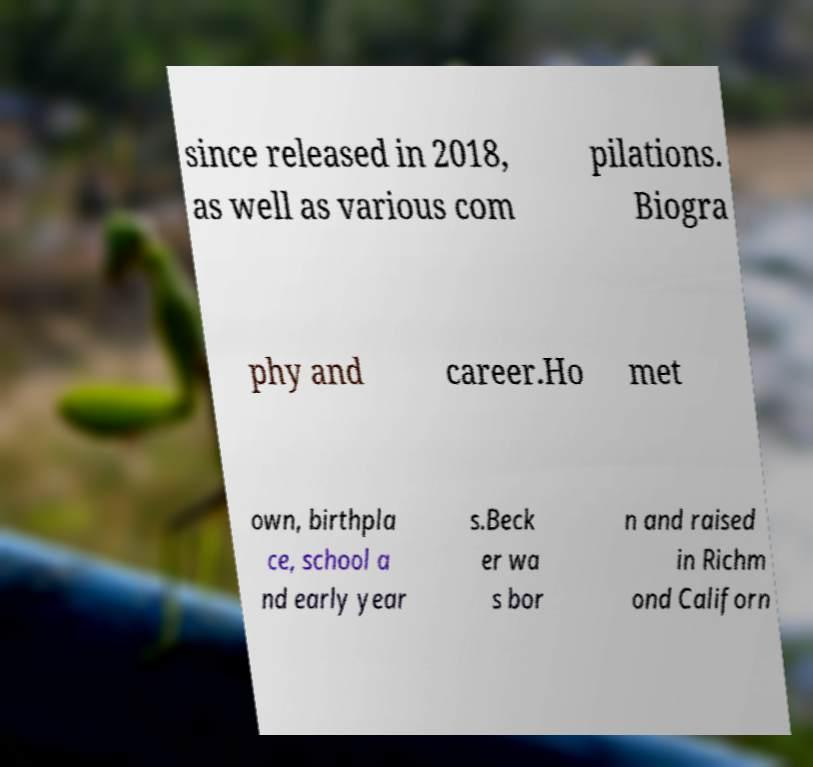Could you extract and type out the text from this image? since released in 2018, as well as various com pilations. Biogra phy and career.Ho met own, birthpla ce, school a nd early year s.Beck er wa s bor n and raised in Richm ond Californ 